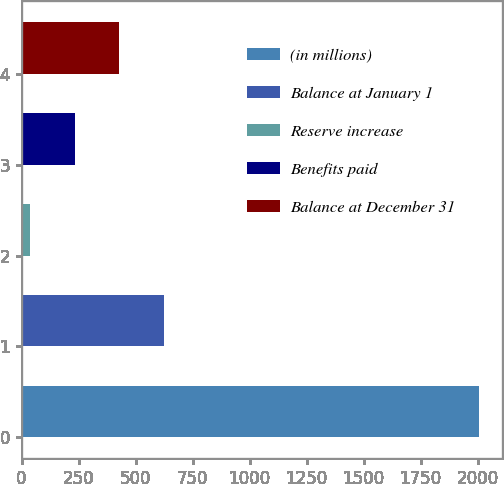<chart> <loc_0><loc_0><loc_500><loc_500><bar_chart><fcel>(in millions)<fcel>Balance at January 1<fcel>Reserve increase<fcel>Benefits paid<fcel>Balance at December 31<nl><fcel>2006<fcel>626.3<fcel>35<fcel>232.1<fcel>429.2<nl></chart> 